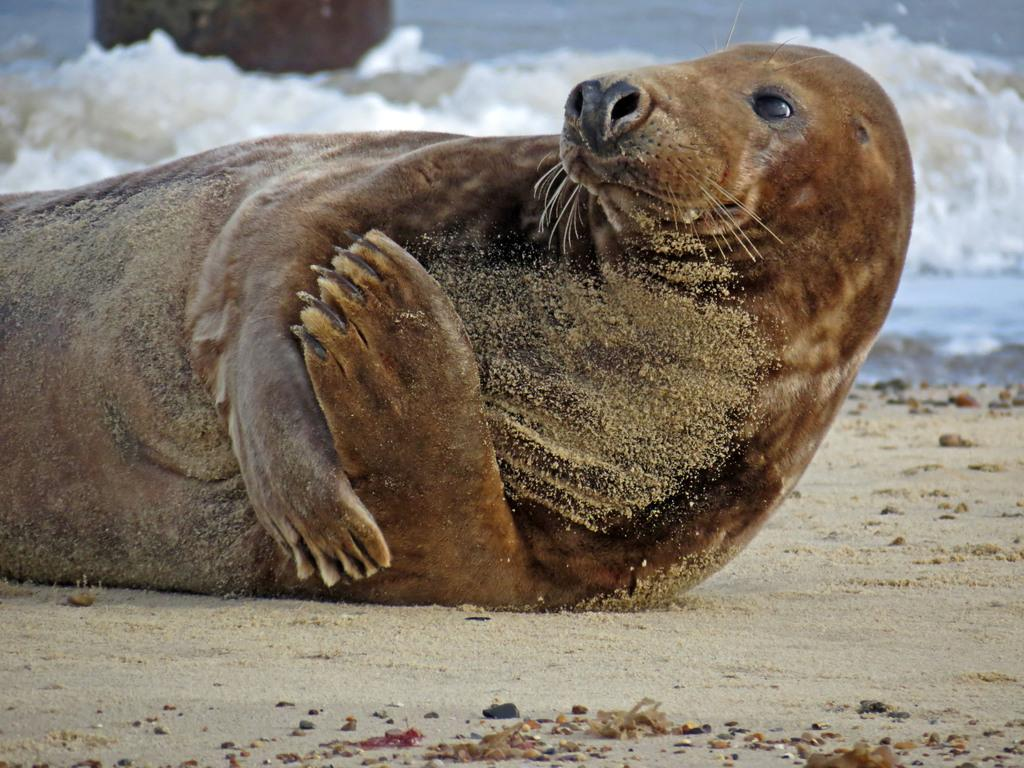What type of animal is in the image? There is a sea lion in the image. What is the sea lion standing on? The sea lion is on a sand surface. What can be seen in the background of the image? There is water visible in the image. What type of advice can be given by the sea lion in the image? There is no indication in the image that the sea lion is giving advice, as animals do not communicate in the same way as humans. 